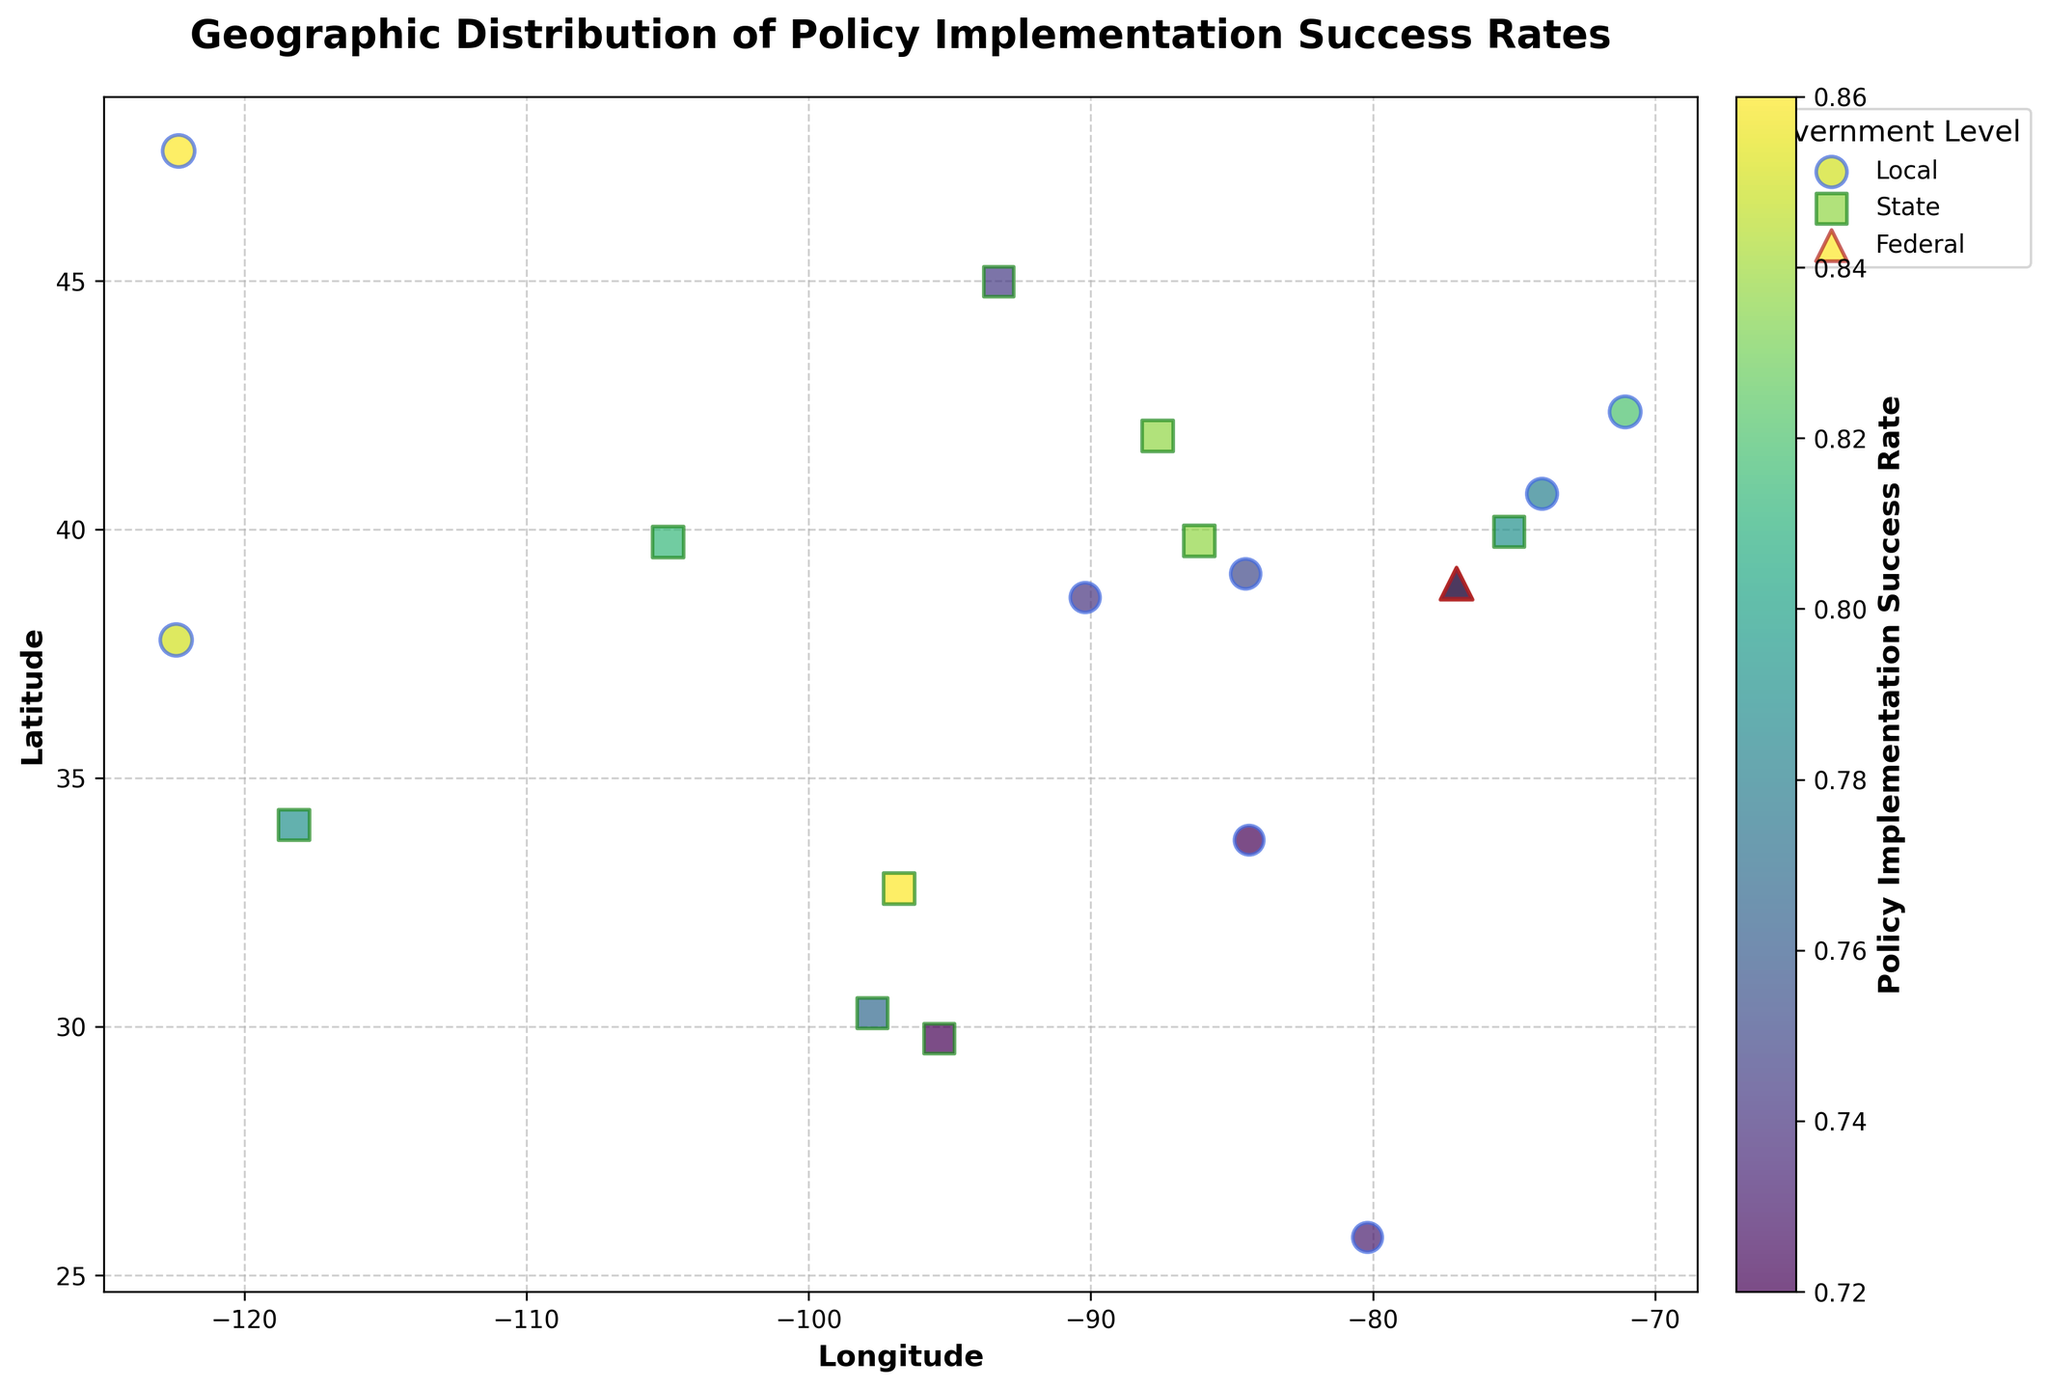Which level of government has the highest policy implementation success rate? By inspecting the color bar, we see that darker green colors represent higher success rates. Washington, D.C., marked by the federal level, has the highest success rate (0.88) compared to other data points on the graph.
Answer: Federal How many data points represent the policy implementation at the state level? By examining the legend and counting the markers that match the state's color and shape, there are a total of 8 state-level data points.
Answer: 8 Which policy area has the highest success rate at the local government level? By referring to the labels and the color intensity corresponding to local government markers, San Francisco's Housing policy has a success rate of 0.85, which is the highest among local policy areas.
Answer: Housing What is the overall range of the policy implementation success rates shown in the plot? The color bar ranges from the lowest value of 0.72 to the highest value of 0.88.
Answer: 0.72 to 0.88 What are the longitude and latitude of the state-level policy area with the lowest success rate? By identifying the policy area with the least color intensity among state-level points, the data point for state-level Energy in Houston has the lowest success rate of 0.76 and is located at the longitude and latitude (-95.3698, 29.7604).
Answer: (-95.3698, 29.7604) Which policy area implemented by the federal government has the highest success rate? Reviewing federal government points and their corresponding success rates, the Defense policy in Washington, D.C., has the highest success rate of 0.88.
Answer: Defense Compare the success rates between local government policy areas in the Western US and Eastern US. Local government success rates in San Francisco, Seattle, and Miami are 0.85, 0.86, and 0.73 respectively for the Western US. In the Eastern US, New York and Boston's success rates are 0.78 and 0.82 respectively. This shows that local policies in the Western US generally have higher success rates.
Answer: Western US generally higher What does the size of each marker represent in the plot? The size of each marker is proportional to the policy implementation success rate of each data point. Larger markers indicate higher success rates.
Answer: Success rate How does the success rate of local Education policy in Atlanta compare to the federal-level average success rate? The success rate of local Education policy in Atlanta is 0.72. The federal-level success rates for Defense, Immigration, and Trade are 0.88, 0.83, and 0.75 respectively, making the average approximately 0.82. The local Education policy in Atlanta has a lower success rate in comparison.
Answer: Lower Identify the geographic area where federal policies have all been implemented and explain its significance. All federal policies are implemented in Washington, D.C. This signifies the centralization of federal policy efforts and shows that Washington, D.C. is a key area for federal policy implementation.
Answer: Washington, D.C 